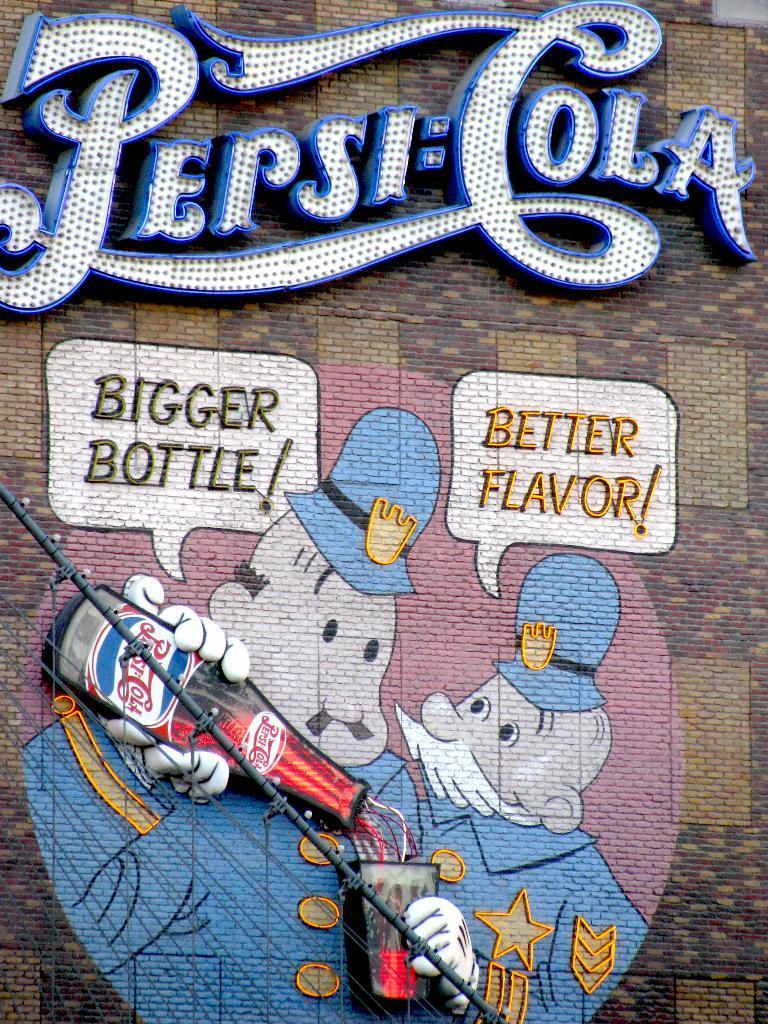In one or two sentences, can you explain what this image depicts? In this image there is a wall and we can see name boards placed on the wall and we can see a painting on the wall. 